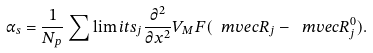<formula> <loc_0><loc_0><loc_500><loc_500>\alpha _ { s } = \frac { 1 } { N _ { p } } \sum \lim i t s _ { j } \frac { \partial ^ { 2 } } { \partial x ^ { 2 } } V _ { M } F ( \ m v e c { R } _ { j } - \ m v e c { R } _ { j } ^ { 0 } ) .</formula> 